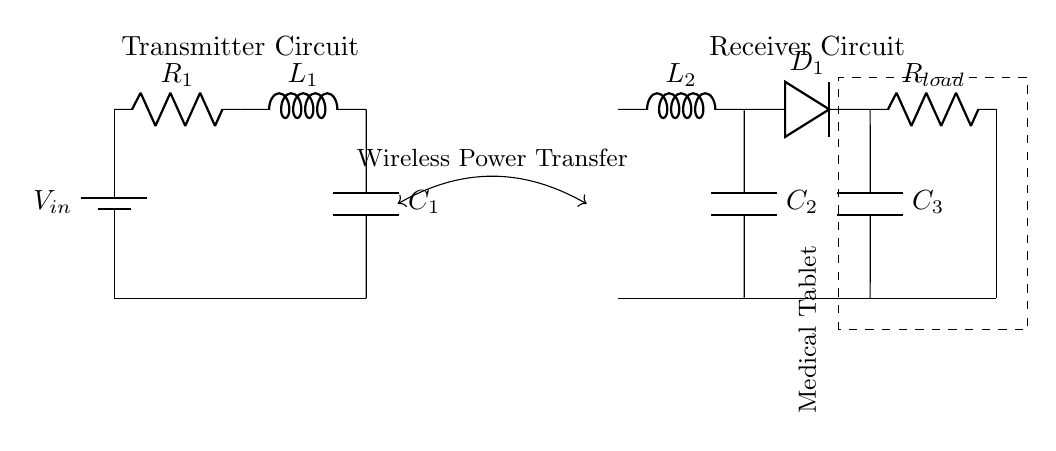What is the input voltage of the transmitter? The input voltage of the transmitter is represented by the label V_in at the battery component.
Answer: V_in What types of components are present in the transmitter section? The transmitter section consists of a battery, resistor, inductor, and capacitor as indicated by their labels and symbols.
Answer: Battery, resistor, inductor, capacitor What is the role of the inductor L1 in the circuit? L1 is used to store energy in its magnetic field, which is essential for the operation of the wireless power transfer system by supporting oscillation.
Answer: Energy storage What is the load resistance in the receiver circuit? The load resistance is denoted by R_load and is indicated within the receiver circuit near the output.
Answer: R_load How is the power transferred wirelessly between the transmitter and receiver? The power is transferred wirelessly through electromagnetic induction, indicated by the arrow labeled "Wireless Power Transfer" connecting both circuits.
Answer: Electromagnetic induction What is the purpose of capacitor C2 in the receiver circuit? C2 is typically used for filtering, smoothing out voltage changes, and stabilizing the output to the medical tablet by helping to ensure a consistent power supply.
Answer: Filtering 